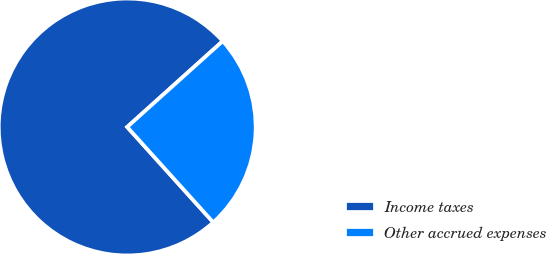Convert chart. <chart><loc_0><loc_0><loc_500><loc_500><pie_chart><fcel>Income taxes<fcel>Other accrued expenses<nl><fcel>75.03%<fcel>24.97%<nl></chart> 